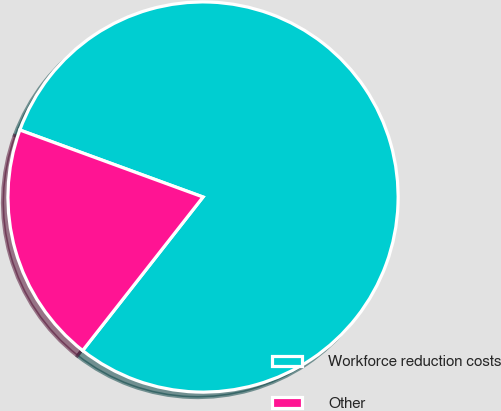<chart> <loc_0><loc_0><loc_500><loc_500><pie_chart><fcel>Workforce reduction costs<fcel>Other<nl><fcel>80.0%<fcel>20.0%<nl></chart> 